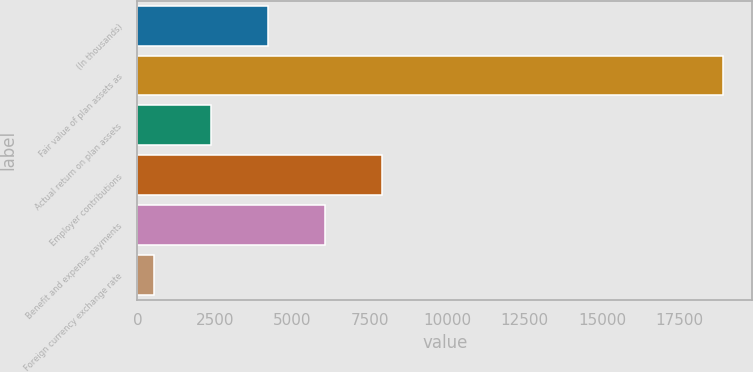<chart> <loc_0><loc_0><loc_500><loc_500><bar_chart><fcel>(In thousands)<fcel>Fair value of plan assets as<fcel>Actual return on plan assets<fcel>Employer contributions<fcel>Benefit and expense payments<fcel>Foreign currency exchange rate<nl><fcel>4214.8<fcel>18894<fcel>2379.9<fcel>7884.6<fcel>6049.7<fcel>545<nl></chart> 